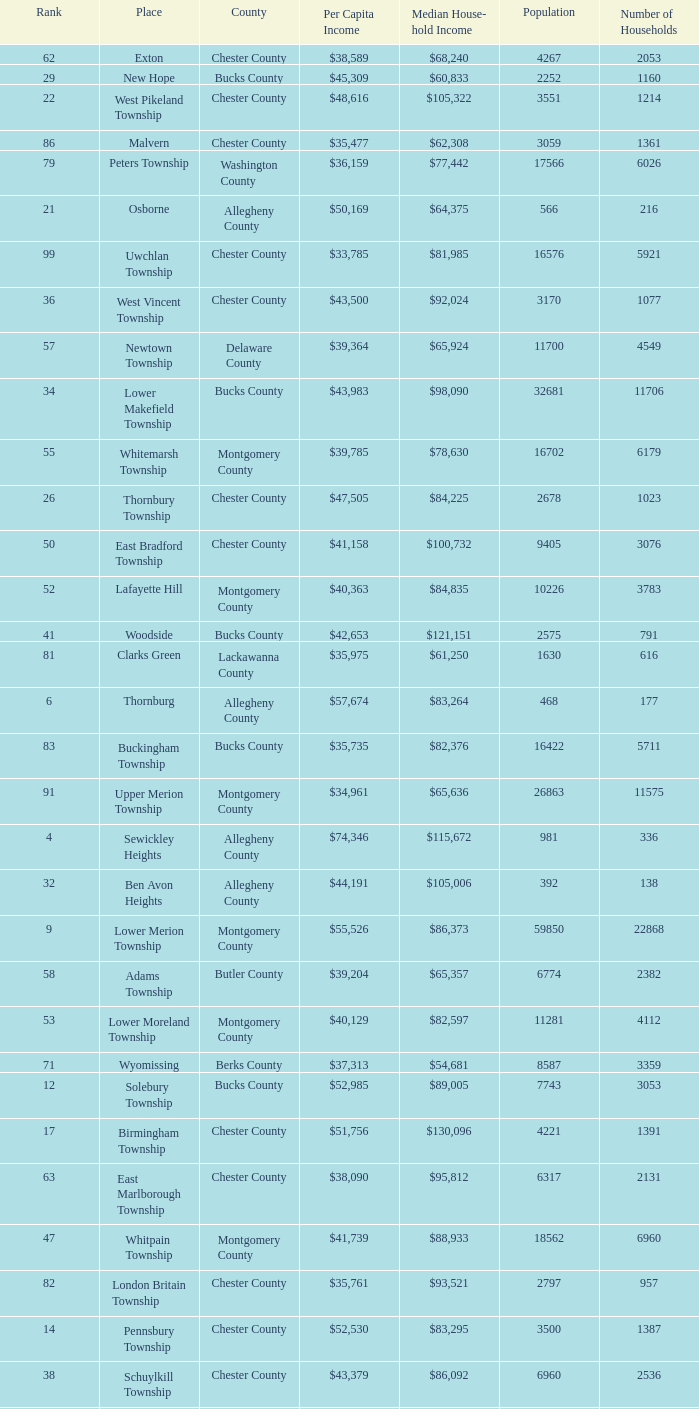What county has 2053 households?  Chester County. 